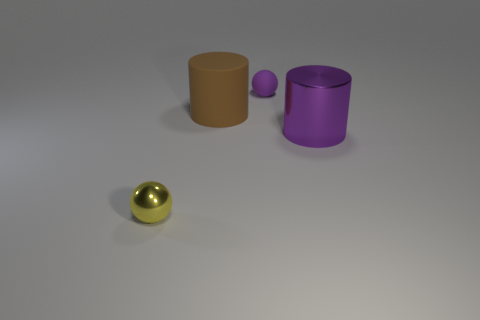Add 1 purple cylinders. How many objects exist? 5 Subtract 2 spheres. How many spheres are left? 0 Add 1 small rubber balls. How many small rubber balls exist? 2 Subtract 0 yellow cylinders. How many objects are left? 4 Subtract all purple spheres. Subtract all cyan cubes. How many spheres are left? 1 Subtract all brown blocks. How many purple balls are left? 1 Subtract all big red blocks. Subtract all large purple cylinders. How many objects are left? 3 Add 1 purple matte balls. How many purple matte balls are left? 2 